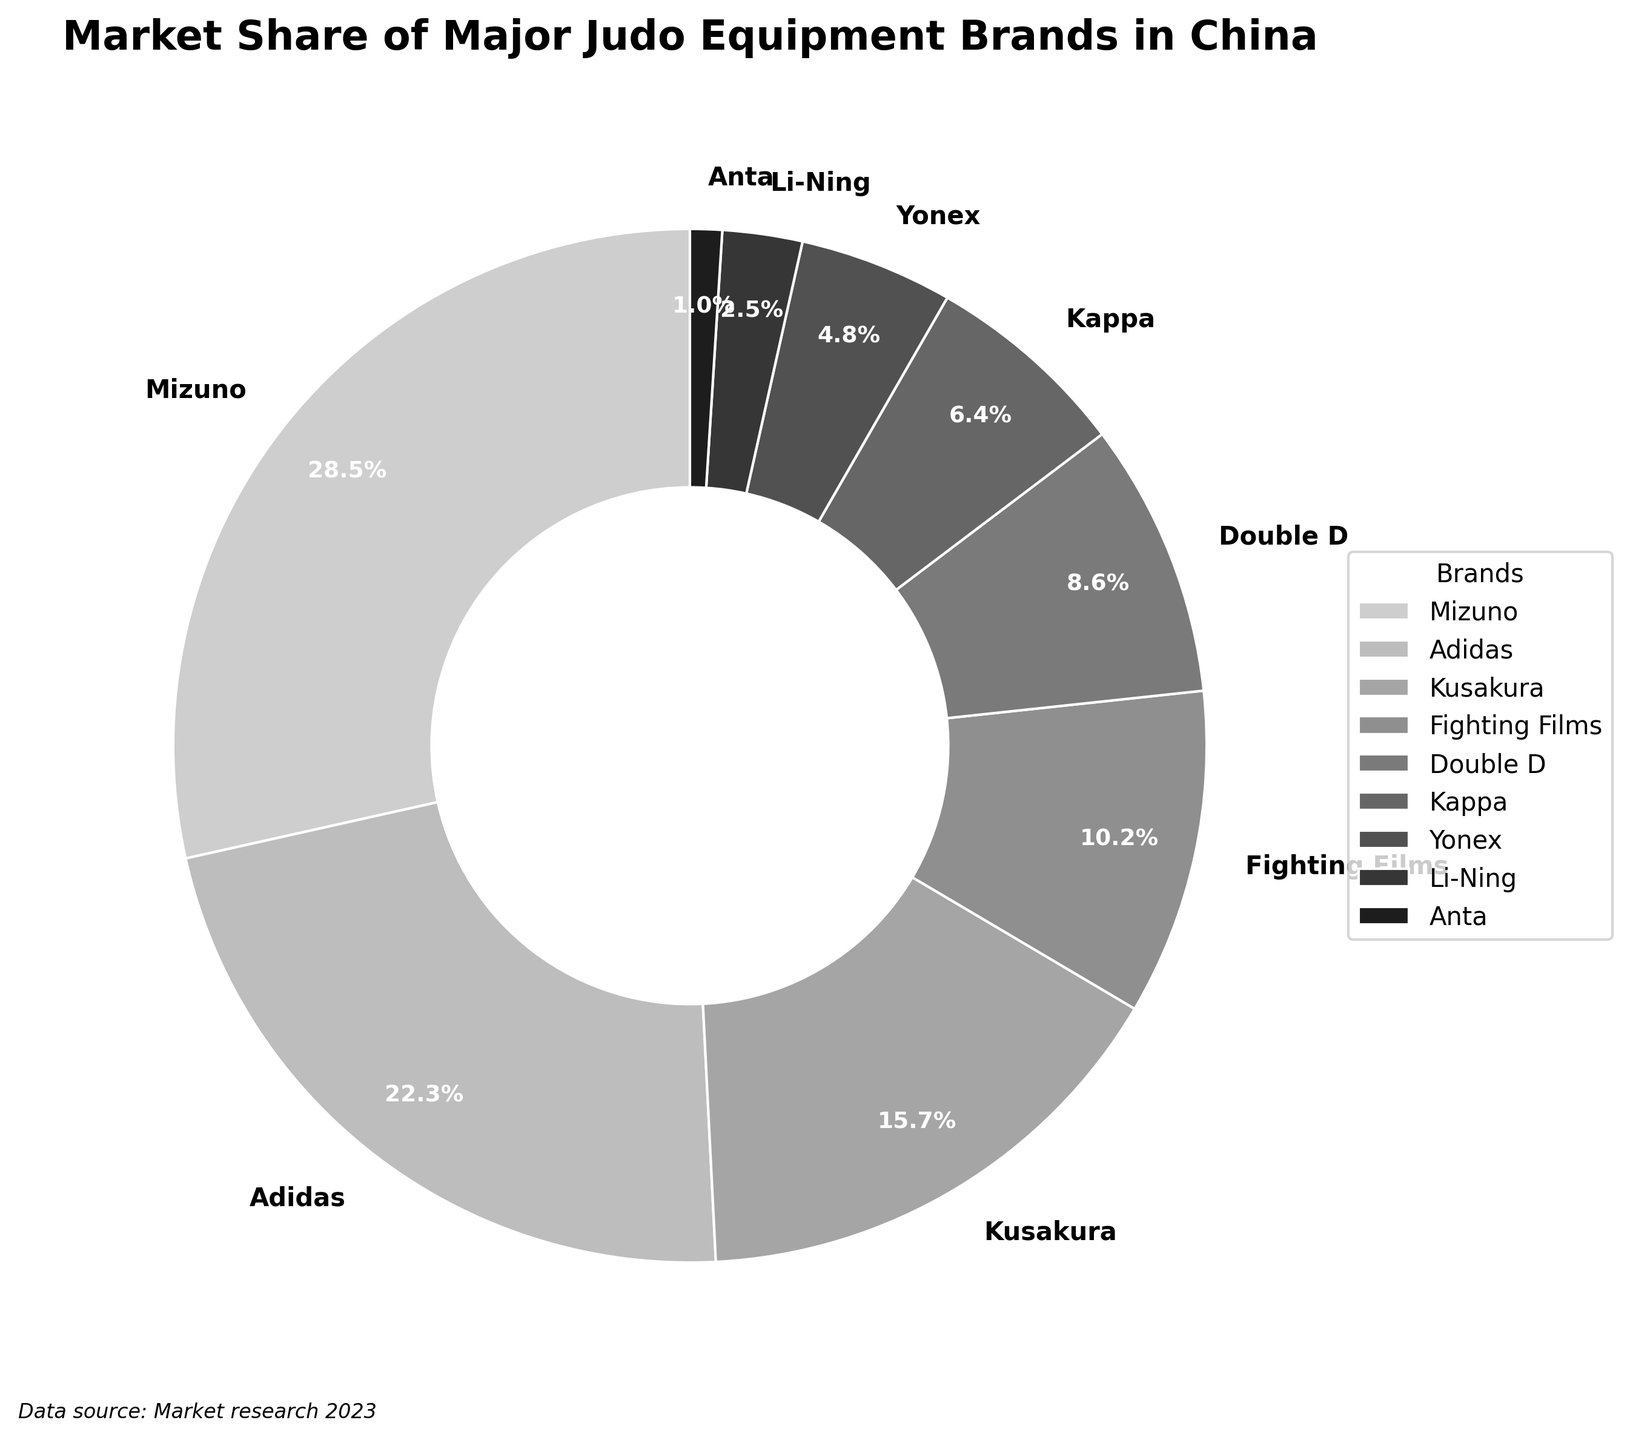What is the market share of Mizuno? From the pie chart, find the segment labeled "Mizuno" and note the percentage inside the segment.
Answer: 28.5% Which brand has the smallest market share, and what is its percentage? Identify the smallest segment in the pie chart and read its label and percentage.
Answer: Anta, 1.0% What is the sum of the market shares of Adidas and Kusakura? Locate the segments labeled "Adidas" and "Kusakura" and sum their percentages: 22.3% + 15.7% = 38.0%.
Answer: 38.0% How much larger is Mizuno’s market share compared to Yonex’s market share? Find the percentages for Mizuno and Yonex and subtract the smaller from the larger: 28.5% - 4.8% = 23.7%.
Answer: 23.7% Which brand has a higher market share, Kappa or Double D, and by how much? Identify the segments labeled "Kappa" and "Double D" and subtract Kappa’s percentage from Double D’s: 8.6% - 6.4% = 2.2%.
Answer: Double D, 2.2% Do Adidas and Fighting Films together have a greater market share than Mizuno? Add the market shares of Adidas and Fighting Films: 22.3% + 10.2% = 32.5%, and compare it to Mizuno's market share: 32.5% > 28.5%.
Answer: Yes List the brands with market shares greater than 10%. Identify and list the segments with percentages higher than 10%.
Answer: Mizuno, Adidas, Kusakura, Fighting Films Calculate the average market share of Double D, Kappa, and Yonex. Sum the market shares of Double D, Kappa, and Yonex, and divide by 3: (8.6% + 6.4% + 4.8%) / 3 = 6.6%.
Answer: 6.6% What percentage of the market is captured by brands with less than 5% share each? Identify segments with less than 5% share, sum their percentages: Yonex (4.8%) + Li-Ning (2.5%) + Anta (1.0%) = 8.3%.
Answer: 8.3% Is the combined market share of Li-Ning and Anta less than Yonex's market share? Sum the percentages of Li-Ning and Anta and compare to Yonex: 2.5% + 1.0% = 3.5%, and 3.5% < 4.8%.
Answer: Yes 